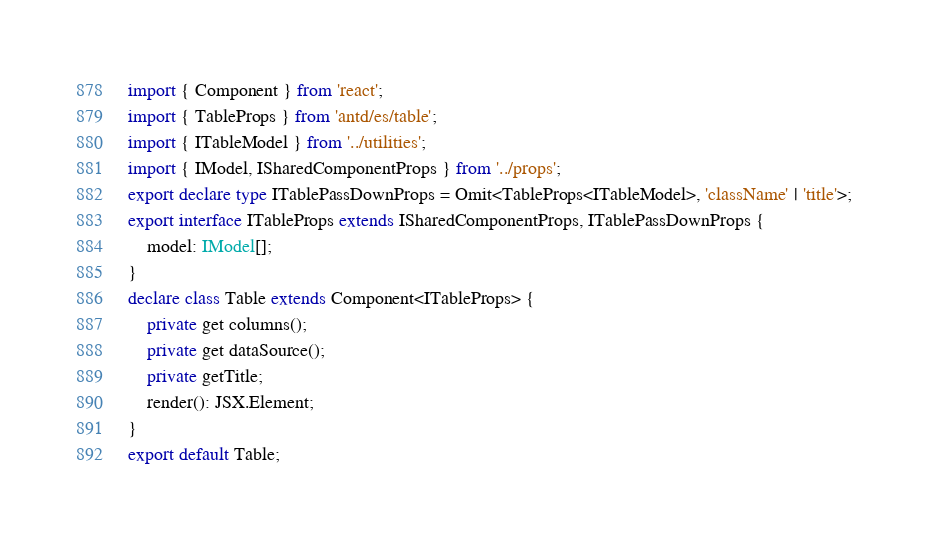<code> <loc_0><loc_0><loc_500><loc_500><_TypeScript_>import { Component } from 'react';
import { TableProps } from 'antd/es/table';
import { ITableModel } from '../utilities';
import { IModel, ISharedComponentProps } from '../props';
export declare type ITablePassDownProps = Omit<TableProps<ITableModel>, 'className' | 'title'>;
export interface ITableProps extends ISharedComponentProps, ITablePassDownProps {
    model: IModel[];
}
declare class Table extends Component<ITableProps> {
    private get columns();
    private get dataSource();
    private getTitle;
    render(): JSX.Element;
}
export default Table;
</code> 